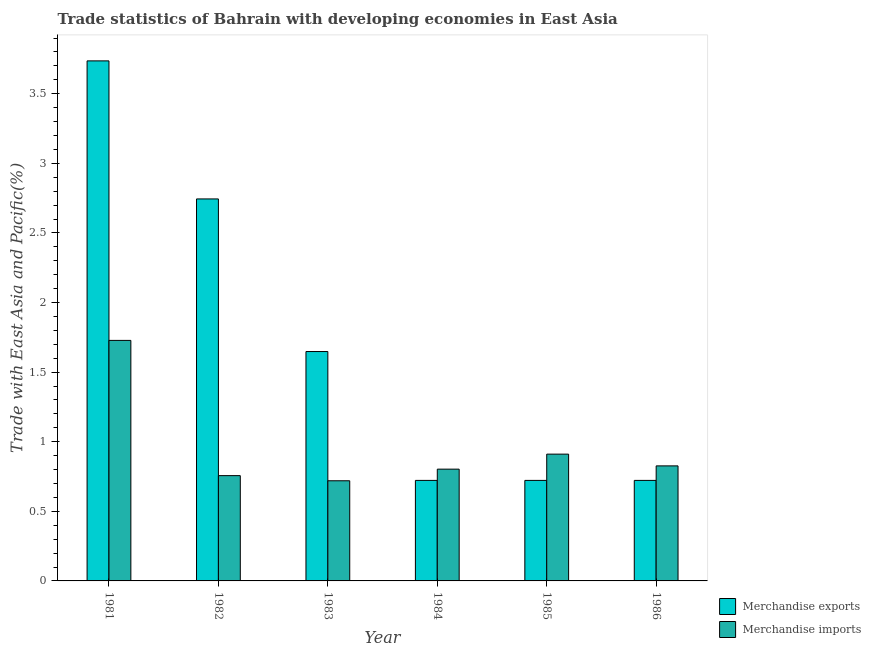How many different coloured bars are there?
Offer a very short reply. 2. Are the number of bars per tick equal to the number of legend labels?
Offer a very short reply. Yes. How many bars are there on the 2nd tick from the left?
Offer a very short reply. 2. How many bars are there on the 1st tick from the right?
Keep it short and to the point. 2. In how many cases, is the number of bars for a given year not equal to the number of legend labels?
Make the answer very short. 0. What is the merchandise exports in 1984?
Give a very brief answer. 0.72. Across all years, what is the maximum merchandise imports?
Provide a short and direct response. 1.73. Across all years, what is the minimum merchandise exports?
Keep it short and to the point. 0.72. In which year was the merchandise imports maximum?
Provide a short and direct response. 1981. What is the total merchandise exports in the graph?
Ensure brevity in your answer.  10.29. What is the difference between the merchandise exports in 1983 and that in 1984?
Give a very brief answer. 0.93. What is the difference between the merchandise exports in 1982 and the merchandise imports in 1983?
Give a very brief answer. 1.1. What is the average merchandise imports per year?
Keep it short and to the point. 0.96. What is the ratio of the merchandise exports in 1981 to that in 1983?
Your response must be concise. 2.27. Is the merchandise exports in 1981 less than that in 1986?
Provide a short and direct response. No. Is the difference between the merchandise exports in 1981 and 1983 greater than the difference between the merchandise imports in 1981 and 1983?
Your response must be concise. No. What is the difference between the highest and the second highest merchandise exports?
Your answer should be compact. 0.99. What is the difference between the highest and the lowest merchandise imports?
Offer a terse response. 1.01. Is the sum of the merchandise imports in 1984 and 1986 greater than the maximum merchandise exports across all years?
Give a very brief answer. No. What does the 2nd bar from the left in 1984 represents?
Ensure brevity in your answer.  Merchandise imports. What does the 2nd bar from the right in 1983 represents?
Provide a short and direct response. Merchandise exports. Are all the bars in the graph horizontal?
Offer a terse response. No. What is the difference between two consecutive major ticks on the Y-axis?
Ensure brevity in your answer.  0.5. Are the values on the major ticks of Y-axis written in scientific E-notation?
Ensure brevity in your answer.  No. Where does the legend appear in the graph?
Ensure brevity in your answer.  Bottom right. What is the title of the graph?
Offer a terse response. Trade statistics of Bahrain with developing economies in East Asia. Does "Lowest 20% of population" appear as one of the legend labels in the graph?
Offer a terse response. No. What is the label or title of the X-axis?
Your response must be concise. Year. What is the label or title of the Y-axis?
Provide a short and direct response. Trade with East Asia and Pacific(%). What is the Trade with East Asia and Pacific(%) in Merchandise exports in 1981?
Make the answer very short. 3.74. What is the Trade with East Asia and Pacific(%) in Merchandise imports in 1981?
Provide a short and direct response. 1.73. What is the Trade with East Asia and Pacific(%) in Merchandise exports in 1982?
Make the answer very short. 2.74. What is the Trade with East Asia and Pacific(%) in Merchandise imports in 1982?
Offer a very short reply. 0.76. What is the Trade with East Asia and Pacific(%) in Merchandise exports in 1983?
Provide a succinct answer. 1.65. What is the Trade with East Asia and Pacific(%) in Merchandise imports in 1983?
Provide a succinct answer. 0.72. What is the Trade with East Asia and Pacific(%) of Merchandise exports in 1984?
Make the answer very short. 0.72. What is the Trade with East Asia and Pacific(%) in Merchandise imports in 1984?
Make the answer very short. 0.8. What is the Trade with East Asia and Pacific(%) in Merchandise exports in 1985?
Your answer should be compact. 0.72. What is the Trade with East Asia and Pacific(%) in Merchandise imports in 1985?
Your answer should be very brief. 0.91. What is the Trade with East Asia and Pacific(%) of Merchandise exports in 1986?
Offer a terse response. 0.72. What is the Trade with East Asia and Pacific(%) of Merchandise imports in 1986?
Keep it short and to the point. 0.83. Across all years, what is the maximum Trade with East Asia and Pacific(%) of Merchandise exports?
Provide a succinct answer. 3.74. Across all years, what is the maximum Trade with East Asia and Pacific(%) of Merchandise imports?
Your response must be concise. 1.73. Across all years, what is the minimum Trade with East Asia and Pacific(%) of Merchandise exports?
Offer a very short reply. 0.72. Across all years, what is the minimum Trade with East Asia and Pacific(%) in Merchandise imports?
Offer a very short reply. 0.72. What is the total Trade with East Asia and Pacific(%) in Merchandise exports in the graph?
Your response must be concise. 10.29. What is the total Trade with East Asia and Pacific(%) in Merchandise imports in the graph?
Keep it short and to the point. 5.74. What is the difference between the Trade with East Asia and Pacific(%) in Merchandise exports in 1981 and that in 1982?
Offer a very short reply. 0.99. What is the difference between the Trade with East Asia and Pacific(%) in Merchandise imports in 1981 and that in 1982?
Give a very brief answer. 0.97. What is the difference between the Trade with East Asia and Pacific(%) of Merchandise exports in 1981 and that in 1983?
Make the answer very short. 2.09. What is the difference between the Trade with East Asia and Pacific(%) of Merchandise imports in 1981 and that in 1983?
Your answer should be very brief. 1.01. What is the difference between the Trade with East Asia and Pacific(%) of Merchandise exports in 1981 and that in 1984?
Keep it short and to the point. 3.01. What is the difference between the Trade with East Asia and Pacific(%) in Merchandise imports in 1981 and that in 1984?
Provide a succinct answer. 0.93. What is the difference between the Trade with East Asia and Pacific(%) in Merchandise exports in 1981 and that in 1985?
Give a very brief answer. 3.01. What is the difference between the Trade with East Asia and Pacific(%) of Merchandise imports in 1981 and that in 1985?
Provide a short and direct response. 0.82. What is the difference between the Trade with East Asia and Pacific(%) of Merchandise exports in 1981 and that in 1986?
Keep it short and to the point. 3.01. What is the difference between the Trade with East Asia and Pacific(%) in Merchandise imports in 1981 and that in 1986?
Give a very brief answer. 0.9. What is the difference between the Trade with East Asia and Pacific(%) of Merchandise exports in 1982 and that in 1983?
Provide a succinct answer. 1.1. What is the difference between the Trade with East Asia and Pacific(%) of Merchandise imports in 1982 and that in 1983?
Your response must be concise. 0.04. What is the difference between the Trade with East Asia and Pacific(%) of Merchandise exports in 1982 and that in 1984?
Your answer should be very brief. 2.02. What is the difference between the Trade with East Asia and Pacific(%) in Merchandise imports in 1982 and that in 1984?
Your answer should be very brief. -0.05. What is the difference between the Trade with East Asia and Pacific(%) in Merchandise exports in 1982 and that in 1985?
Keep it short and to the point. 2.02. What is the difference between the Trade with East Asia and Pacific(%) in Merchandise imports in 1982 and that in 1985?
Your response must be concise. -0.15. What is the difference between the Trade with East Asia and Pacific(%) in Merchandise exports in 1982 and that in 1986?
Make the answer very short. 2.02. What is the difference between the Trade with East Asia and Pacific(%) in Merchandise imports in 1982 and that in 1986?
Your answer should be very brief. -0.07. What is the difference between the Trade with East Asia and Pacific(%) in Merchandise exports in 1983 and that in 1984?
Provide a succinct answer. 0.93. What is the difference between the Trade with East Asia and Pacific(%) in Merchandise imports in 1983 and that in 1984?
Give a very brief answer. -0.08. What is the difference between the Trade with East Asia and Pacific(%) of Merchandise exports in 1983 and that in 1985?
Your answer should be compact. 0.93. What is the difference between the Trade with East Asia and Pacific(%) of Merchandise imports in 1983 and that in 1985?
Offer a very short reply. -0.19. What is the difference between the Trade with East Asia and Pacific(%) in Merchandise exports in 1983 and that in 1986?
Provide a succinct answer. 0.93. What is the difference between the Trade with East Asia and Pacific(%) in Merchandise imports in 1983 and that in 1986?
Keep it short and to the point. -0.11. What is the difference between the Trade with East Asia and Pacific(%) in Merchandise exports in 1984 and that in 1985?
Your answer should be very brief. -0. What is the difference between the Trade with East Asia and Pacific(%) of Merchandise imports in 1984 and that in 1985?
Offer a very short reply. -0.11. What is the difference between the Trade with East Asia and Pacific(%) of Merchandise exports in 1984 and that in 1986?
Provide a short and direct response. 0. What is the difference between the Trade with East Asia and Pacific(%) of Merchandise imports in 1984 and that in 1986?
Your answer should be very brief. -0.02. What is the difference between the Trade with East Asia and Pacific(%) of Merchandise exports in 1985 and that in 1986?
Keep it short and to the point. 0. What is the difference between the Trade with East Asia and Pacific(%) in Merchandise imports in 1985 and that in 1986?
Your answer should be compact. 0.08. What is the difference between the Trade with East Asia and Pacific(%) of Merchandise exports in 1981 and the Trade with East Asia and Pacific(%) of Merchandise imports in 1982?
Keep it short and to the point. 2.98. What is the difference between the Trade with East Asia and Pacific(%) of Merchandise exports in 1981 and the Trade with East Asia and Pacific(%) of Merchandise imports in 1983?
Your response must be concise. 3.02. What is the difference between the Trade with East Asia and Pacific(%) in Merchandise exports in 1981 and the Trade with East Asia and Pacific(%) in Merchandise imports in 1984?
Give a very brief answer. 2.93. What is the difference between the Trade with East Asia and Pacific(%) in Merchandise exports in 1981 and the Trade with East Asia and Pacific(%) in Merchandise imports in 1985?
Offer a very short reply. 2.83. What is the difference between the Trade with East Asia and Pacific(%) of Merchandise exports in 1981 and the Trade with East Asia and Pacific(%) of Merchandise imports in 1986?
Ensure brevity in your answer.  2.91. What is the difference between the Trade with East Asia and Pacific(%) of Merchandise exports in 1982 and the Trade with East Asia and Pacific(%) of Merchandise imports in 1983?
Provide a short and direct response. 2.02. What is the difference between the Trade with East Asia and Pacific(%) of Merchandise exports in 1982 and the Trade with East Asia and Pacific(%) of Merchandise imports in 1984?
Offer a very short reply. 1.94. What is the difference between the Trade with East Asia and Pacific(%) of Merchandise exports in 1982 and the Trade with East Asia and Pacific(%) of Merchandise imports in 1985?
Ensure brevity in your answer.  1.83. What is the difference between the Trade with East Asia and Pacific(%) in Merchandise exports in 1982 and the Trade with East Asia and Pacific(%) in Merchandise imports in 1986?
Your response must be concise. 1.92. What is the difference between the Trade with East Asia and Pacific(%) in Merchandise exports in 1983 and the Trade with East Asia and Pacific(%) in Merchandise imports in 1984?
Offer a very short reply. 0.84. What is the difference between the Trade with East Asia and Pacific(%) in Merchandise exports in 1983 and the Trade with East Asia and Pacific(%) in Merchandise imports in 1985?
Provide a succinct answer. 0.74. What is the difference between the Trade with East Asia and Pacific(%) of Merchandise exports in 1983 and the Trade with East Asia and Pacific(%) of Merchandise imports in 1986?
Your answer should be very brief. 0.82. What is the difference between the Trade with East Asia and Pacific(%) of Merchandise exports in 1984 and the Trade with East Asia and Pacific(%) of Merchandise imports in 1985?
Your answer should be very brief. -0.19. What is the difference between the Trade with East Asia and Pacific(%) in Merchandise exports in 1984 and the Trade with East Asia and Pacific(%) in Merchandise imports in 1986?
Provide a short and direct response. -0.1. What is the difference between the Trade with East Asia and Pacific(%) in Merchandise exports in 1985 and the Trade with East Asia and Pacific(%) in Merchandise imports in 1986?
Make the answer very short. -0.1. What is the average Trade with East Asia and Pacific(%) of Merchandise exports per year?
Offer a terse response. 1.72. What is the average Trade with East Asia and Pacific(%) in Merchandise imports per year?
Your answer should be very brief. 0.96. In the year 1981, what is the difference between the Trade with East Asia and Pacific(%) in Merchandise exports and Trade with East Asia and Pacific(%) in Merchandise imports?
Your answer should be very brief. 2.01. In the year 1982, what is the difference between the Trade with East Asia and Pacific(%) in Merchandise exports and Trade with East Asia and Pacific(%) in Merchandise imports?
Give a very brief answer. 1.99. In the year 1983, what is the difference between the Trade with East Asia and Pacific(%) of Merchandise exports and Trade with East Asia and Pacific(%) of Merchandise imports?
Provide a succinct answer. 0.93. In the year 1984, what is the difference between the Trade with East Asia and Pacific(%) of Merchandise exports and Trade with East Asia and Pacific(%) of Merchandise imports?
Keep it short and to the point. -0.08. In the year 1985, what is the difference between the Trade with East Asia and Pacific(%) of Merchandise exports and Trade with East Asia and Pacific(%) of Merchandise imports?
Offer a terse response. -0.19. In the year 1986, what is the difference between the Trade with East Asia and Pacific(%) of Merchandise exports and Trade with East Asia and Pacific(%) of Merchandise imports?
Your answer should be compact. -0.1. What is the ratio of the Trade with East Asia and Pacific(%) of Merchandise exports in 1981 to that in 1982?
Your answer should be compact. 1.36. What is the ratio of the Trade with East Asia and Pacific(%) in Merchandise imports in 1981 to that in 1982?
Offer a terse response. 2.28. What is the ratio of the Trade with East Asia and Pacific(%) of Merchandise exports in 1981 to that in 1983?
Make the answer very short. 2.27. What is the ratio of the Trade with East Asia and Pacific(%) of Merchandise imports in 1981 to that in 1983?
Offer a very short reply. 2.4. What is the ratio of the Trade with East Asia and Pacific(%) of Merchandise exports in 1981 to that in 1984?
Offer a terse response. 5.17. What is the ratio of the Trade with East Asia and Pacific(%) in Merchandise imports in 1981 to that in 1984?
Provide a succinct answer. 2.15. What is the ratio of the Trade with East Asia and Pacific(%) in Merchandise exports in 1981 to that in 1985?
Give a very brief answer. 5.17. What is the ratio of the Trade with East Asia and Pacific(%) in Merchandise imports in 1981 to that in 1985?
Offer a terse response. 1.9. What is the ratio of the Trade with East Asia and Pacific(%) of Merchandise exports in 1981 to that in 1986?
Your answer should be compact. 5.17. What is the ratio of the Trade with East Asia and Pacific(%) of Merchandise imports in 1981 to that in 1986?
Keep it short and to the point. 2.09. What is the ratio of the Trade with East Asia and Pacific(%) in Merchandise exports in 1982 to that in 1983?
Your answer should be very brief. 1.67. What is the ratio of the Trade with East Asia and Pacific(%) of Merchandise imports in 1982 to that in 1983?
Make the answer very short. 1.05. What is the ratio of the Trade with East Asia and Pacific(%) of Merchandise exports in 1982 to that in 1984?
Provide a succinct answer. 3.8. What is the ratio of the Trade with East Asia and Pacific(%) of Merchandise imports in 1982 to that in 1984?
Give a very brief answer. 0.94. What is the ratio of the Trade with East Asia and Pacific(%) in Merchandise exports in 1982 to that in 1985?
Provide a succinct answer. 3.8. What is the ratio of the Trade with East Asia and Pacific(%) in Merchandise imports in 1982 to that in 1985?
Provide a short and direct response. 0.83. What is the ratio of the Trade with East Asia and Pacific(%) of Merchandise exports in 1982 to that in 1986?
Ensure brevity in your answer.  3.8. What is the ratio of the Trade with East Asia and Pacific(%) of Merchandise imports in 1982 to that in 1986?
Your answer should be compact. 0.92. What is the ratio of the Trade with East Asia and Pacific(%) in Merchandise exports in 1983 to that in 1984?
Provide a succinct answer. 2.28. What is the ratio of the Trade with East Asia and Pacific(%) in Merchandise imports in 1983 to that in 1984?
Make the answer very short. 0.9. What is the ratio of the Trade with East Asia and Pacific(%) in Merchandise exports in 1983 to that in 1985?
Make the answer very short. 2.28. What is the ratio of the Trade with East Asia and Pacific(%) of Merchandise imports in 1983 to that in 1985?
Offer a very short reply. 0.79. What is the ratio of the Trade with East Asia and Pacific(%) in Merchandise exports in 1983 to that in 1986?
Your response must be concise. 2.28. What is the ratio of the Trade with East Asia and Pacific(%) in Merchandise imports in 1983 to that in 1986?
Your response must be concise. 0.87. What is the ratio of the Trade with East Asia and Pacific(%) in Merchandise exports in 1984 to that in 1985?
Make the answer very short. 1. What is the ratio of the Trade with East Asia and Pacific(%) in Merchandise imports in 1984 to that in 1985?
Provide a succinct answer. 0.88. What is the ratio of the Trade with East Asia and Pacific(%) of Merchandise imports in 1984 to that in 1986?
Make the answer very short. 0.97. What is the ratio of the Trade with East Asia and Pacific(%) in Merchandise exports in 1985 to that in 1986?
Give a very brief answer. 1. What is the ratio of the Trade with East Asia and Pacific(%) of Merchandise imports in 1985 to that in 1986?
Your answer should be very brief. 1.1. What is the difference between the highest and the second highest Trade with East Asia and Pacific(%) of Merchandise imports?
Offer a terse response. 0.82. What is the difference between the highest and the lowest Trade with East Asia and Pacific(%) in Merchandise exports?
Provide a short and direct response. 3.01. What is the difference between the highest and the lowest Trade with East Asia and Pacific(%) in Merchandise imports?
Your response must be concise. 1.01. 